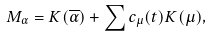<formula> <loc_0><loc_0><loc_500><loc_500>M _ { \alpha } = K ( \overline { \alpha } ) + \sum c _ { \mu } ( t ) K ( \mu ) ,</formula> 